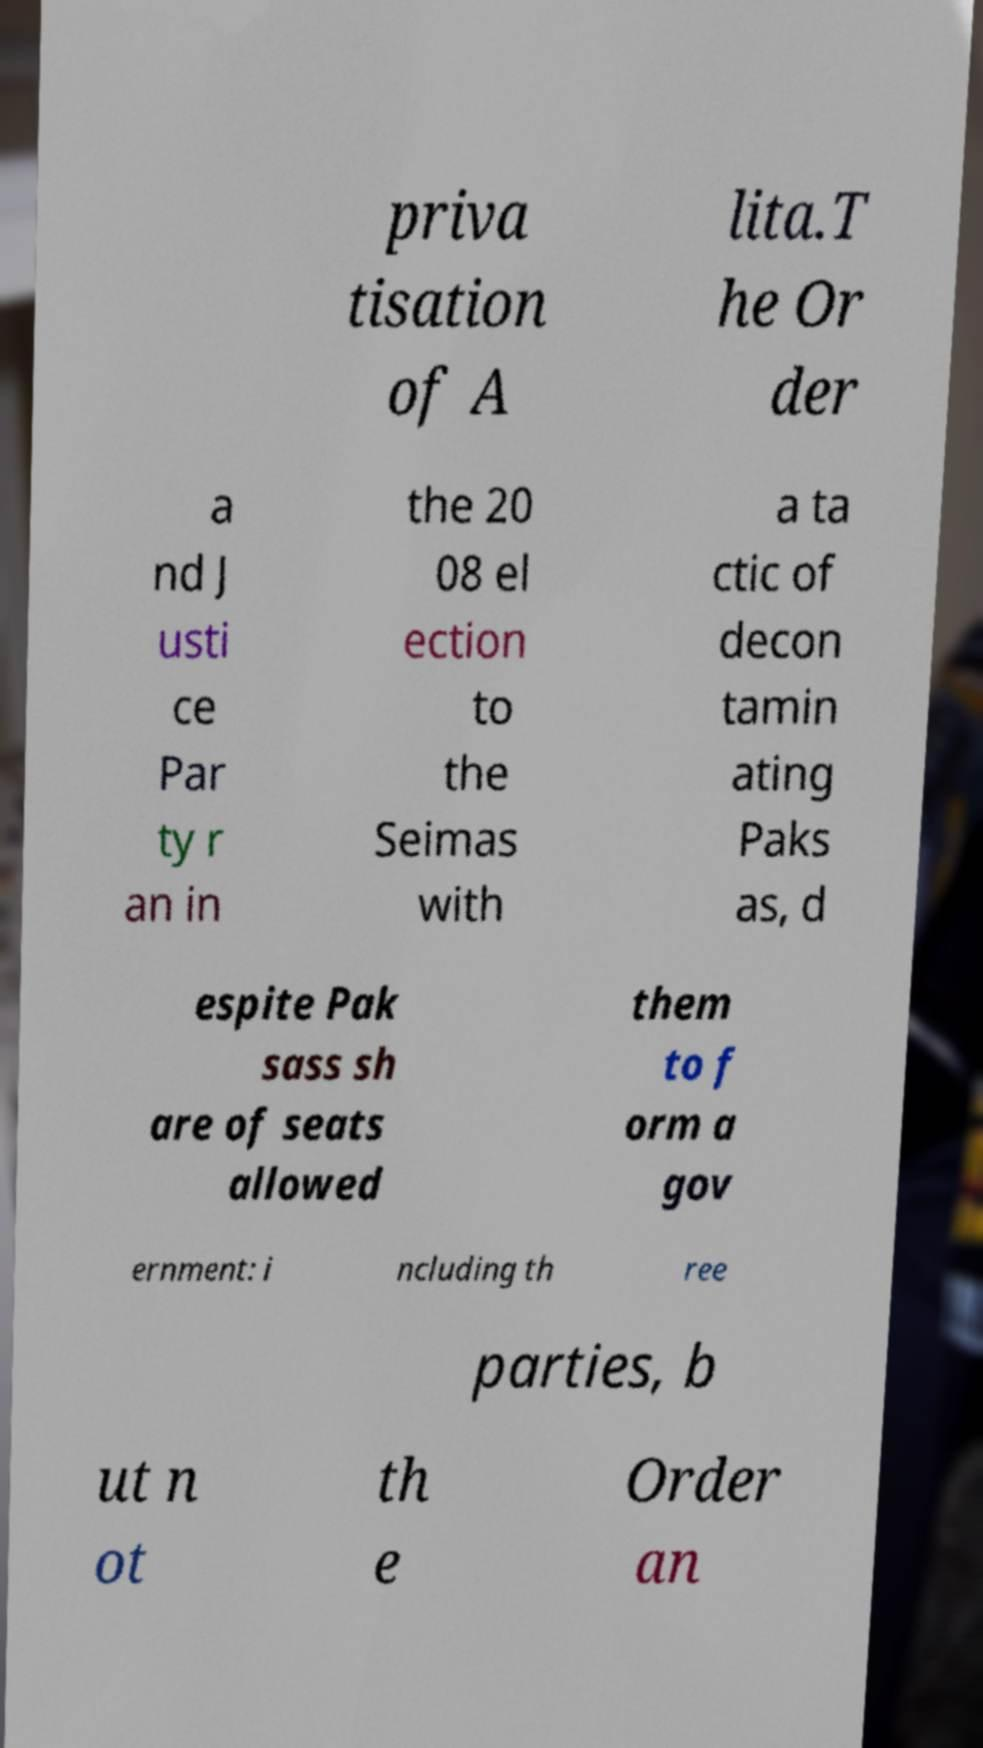Could you extract and type out the text from this image? priva tisation of A lita.T he Or der a nd J usti ce Par ty r an in the 20 08 el ection to the Seimas with a ta ctic of decon tamin ating Paks as, d espite Pak sass sh are of seats allowed them to f orm a gov ernment: i ncluding th ree parties, b ut n ot th e Order an 